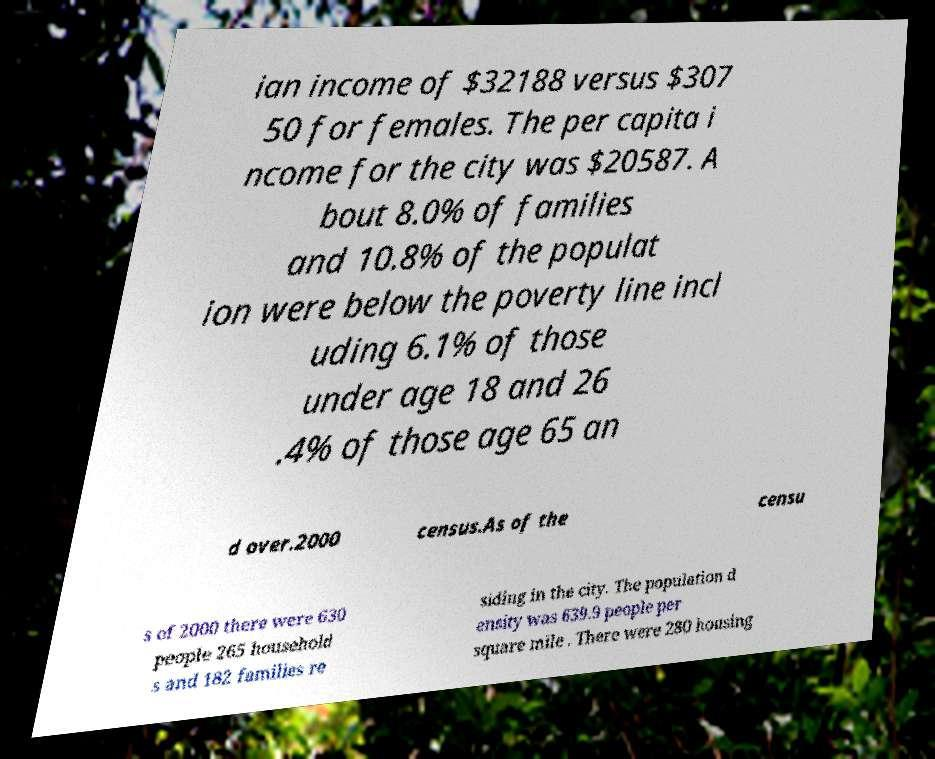Please read and relay the text visible in this image. What does it say? ian income of $32188 versus $307 50 for females. The per capita i ncome for the city was $20587. A bout 8.0% of families and 10.8% of the populat ion were below the poverty line incl uding 6.1% of those under age 18 and 26 .4% of those age 65 an d over.2000 census.As of the censu s of 2000 there were 630 people 265 household s and 182 families re siding in the city. The population d ensity was 639.9 people per square mile . There were 280 housing 